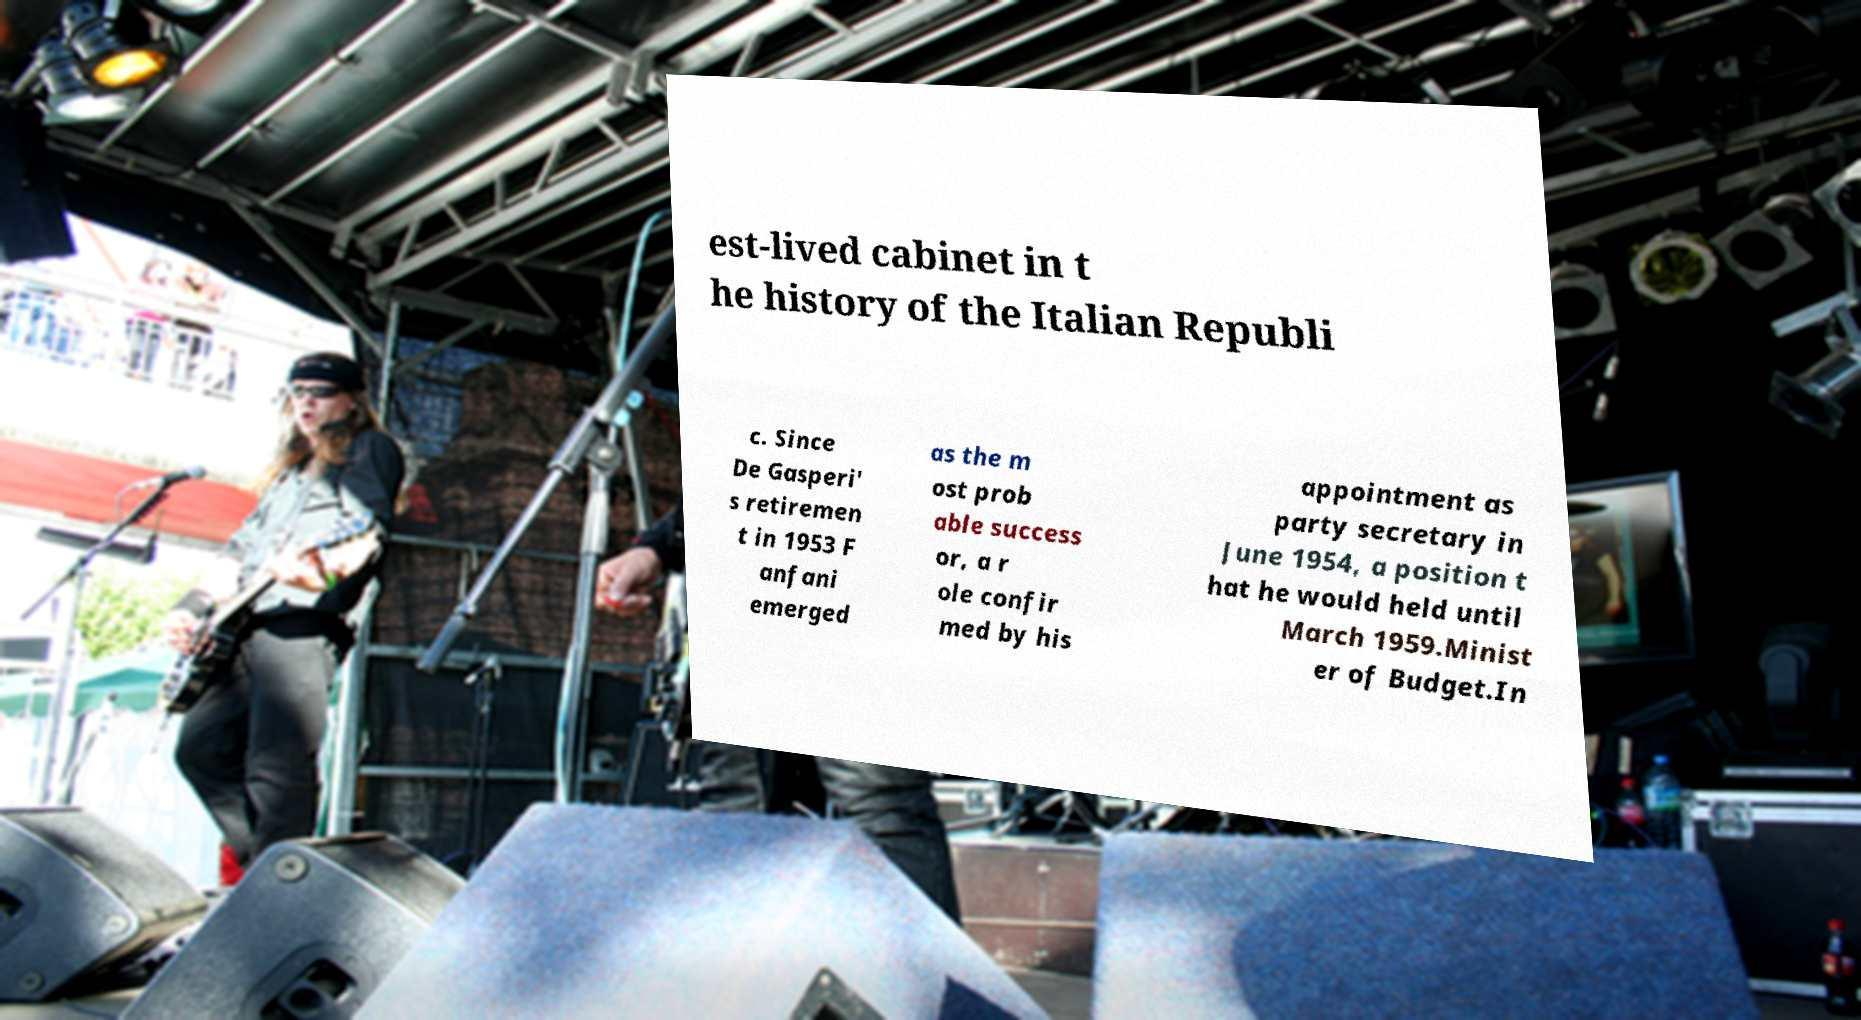Please read and relay the text visible in this image. What does it say? est-lived cabinet in t he history of the Italian Republi c. Since De Gasperi' s retiremen t in 1953 F anfani emerged as the m ost prob able success or, a r ole confir med by his appointment as party secretary in June 1954, a position t hat he would held until March 1959.Minist er of Budget.In 